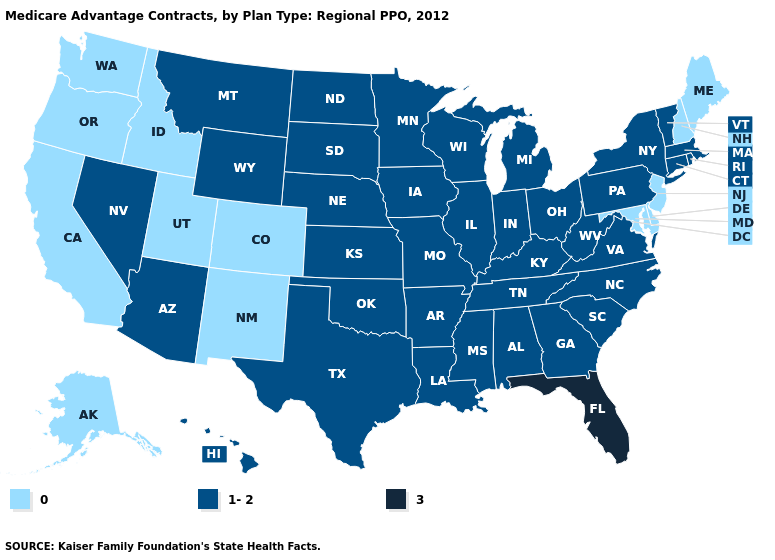What is the value of Rhode Island?
Give a very brief answer. 1-2. Name the states that have a value in the range 1-2?
Keep it brief. Alabama, Arkansas, Arizona, Connecticut, Georgia, Hawaii, Iowa, Illinois, Indiana, Kansas, Kentucky, Louisiana, Massachusetts, Michigan, Minnesota, Missouri, Mississippi, Montana, North Carolina, North Dakota, Nebraska, Nevada, New York, Ohio, Oklahoma, Pennsylvania, Rhode Island, South Carolina, South Dakota, Tennessee, Texas, Virginia, Vermont, Wisconsin, West Virginia, Wyoming. Name the states that have a value in the range 3?
Write a very short answer. Florida. What is the highest value in states that border North Carolina?
Write a very short answer. 1-2. What is the value of Colorado?
Be succinct. 0. Among the states that border New York , does Massachusetts have the lowest value?
Answer briefly. No. Does the first symbol in the legend represent the smallest category?
Concise answer only. Yes. Name the states that have a value in the range 1-2?
Write a very short answer. Alabama, Arkansas, Arizona, Connecticut, Georgia, Hawaii, Iowa, Illinois, Indiana, Kansas, Kentucky, Louisiana, Massachusetts, Michigan, Minnesota, Missouri, Mississippi, Montana, North Carolina, North Dakota, Nebraska, Nevada, New York, Ohio, Oklahoma, Pennsylvania, Rhode Island, South Carolina, South Dakota, Tennessee, Texas, Virginia, Vermont, Wisconsin, West Virginia, Wyoming. Which states have the lowest value in the USA?
Keep it brief. Alaska, California, Colorado, Delaware, Idaho, Maryland, Maine, New Hampshire, New Jersey, New Mexico, Oregon, Utah, Washington. Name the states that have a value in the range 3?
Quick response, please. Florida. What is the value of Kentucky?
Be succinct. 1-2. Which states hav the highest value in the Northeast?
Give a very brief answer. Connecticut, Massachusetts, New York, Pennsylvania, Rhode Island, Vermont. Does Nebraska have a higher value than Idaho?
Concise answer only. Yes. Among the states that border New Hampshire , which have the highest value?
Concise answer only. Massachusetts, Vermont. Among the states that border Alabama , does Florida have the highest value?
Write a very short answer. Yes. 